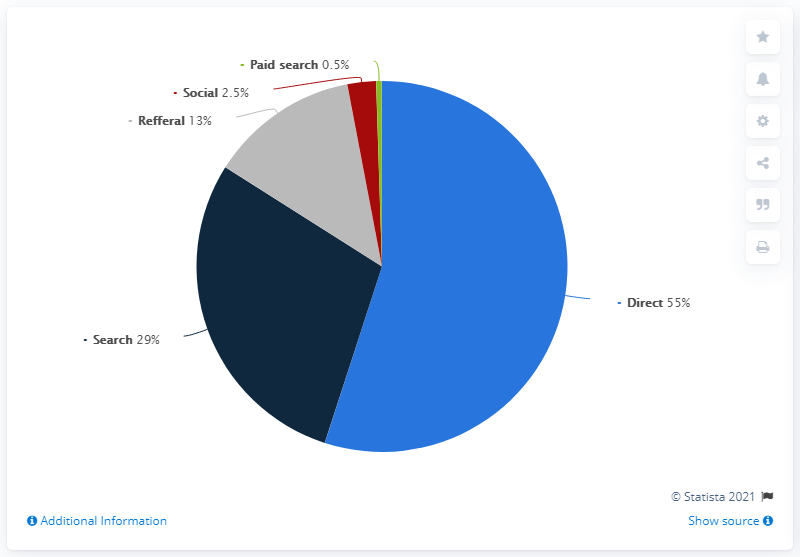Highlight a few significant elements in this photo. As of 2021, the percentage distribution of worldwide websites by search is approximately 29%. The sum of the least three distribution sources is 16. 